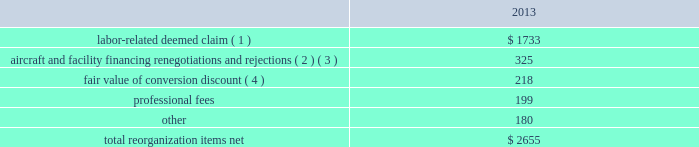Table of contents the following discussion of nonoperating income and expense excludes the results of the merger in order to provide a more meaningful year-over-year comparison .
Interest expense , net of capitalized interest decreased $ 249 million in 2014 from 2013 primarily due to a $ 149 million decrease in special charges recognized year-over-year as further described below , as well as refinancing activities that resulted in $ 100 million less interest expense recognized in 2014 .
( 1 ) in 2014 , we recognized $ 33 million of special charges relating to non-cash interest accretion on bankruptcy settlement obligations .
In 2013 , we recognized $ 138 million of special charges relating to post-petition interest expense on unsecured obligations pursuant to the plan and penalty interest related to american 2019s 10.5% ( 10.5 % ) secured notes and 7.50% ( 7.50 % ) senior secured notes .
In addition , in 2013 we recorded special charges of $ 44 million for debt extinguishment costs incurred as a result of the repayment of certain aircraft secured indebtedness , including cash interest charges and non-cash write offs of unamortized debt issuance costs .
( 2 ) as a result of the 2013 refinancing activities and the early extinguishment of american 2019s 7.50% ( 7.50 % ) senior secured notes in 2014 , we recognized $ 100 million less interest expense in 2014 as compared to 2013 .
Other nonoperating expense , net in 2014 consisted of $ 114 million of net foreign currency losses , including a $ 43 million special charge for venezuelan foreign currency losses , and $ 56 million in other nonoperating special charges primarily due to early debt extinguishment costs related to the prepayment of our 7.50% ( 7.50 % ) senior secured notes and other indebtedness .
The foreign currency losses were driven primarily by the strengthening of the u.s .
Dollar relative to other currencies during 2014 , principally in the latin american market , including a 48% ( 48 % ) decrease in the value of the venezuelan bolivar and a 14% ( 14 % ) decrease in the value of the brazilian real .
Other nonoperating expense , net in 2013 consisted principally of net foreign currency losses of $ 56 million and early debt extinguishment charges of $ 29 million .
Reorganization items , net reorganization items refer to revenues , expenses ( including professional fees ) , realized gains and losses and provisions for losses that are realized or incurred as a direct result of the chapter 11 cases .
The table summarizes the components included in reorganization items , net on aag 2019s consolidated statement of operations for the year ended december 31 , 2013 ( in millions ) : .
( 1 ) in exchange for employees 2019 contributions to the successful reorganization , including agreeing to reductions in pay and benefits , we agreed in the plan to provide each employee group a deemed claim , which was used to provide a distribution of a portion of the equity of the reorganized entity to those employees .
Each employee group received a deemed claim amount based upon a portion of the value of cost savings provided by that group through reductions to pay and benefits as well as through certain work rule changes .
The total value of this deemed claim was approximately $ 1.7 billion .
( 2 ) amounts include allowed claims ( claims approved by the bankruptcy court ) and estimated allowed claims relating to ( i ) the rejection or modification of financings related to aircraft and ( ii ) entry of orders treated as unsecured claims with respect to facility agreements supporting certain issuances of special facility revenue bonds .
The debtors recorded an estimated claim associated with the rejection or modification of a financing .
What percentage of total reorganization items net consisted of labor-deemed claims in 2013? 
Computations: (1733 / 2655)
Answer: 0.65273. 